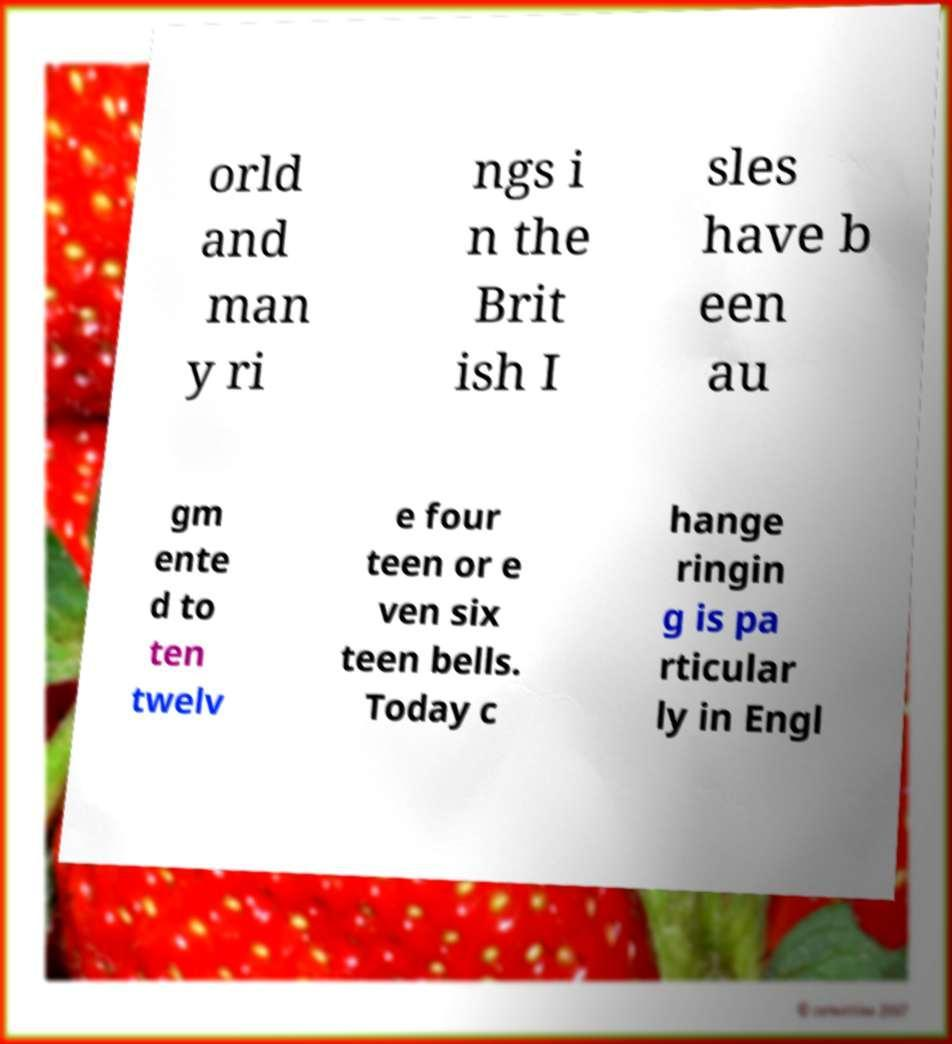What messages or text are displayed in this image? I need them in a readable, typed format. orld and man y ri ngs i n the Brit ish I sles have b een au gm ente d to ten twelv e four teen or e ven six teen bells. Today c hange ringin g is pa rticular ly in Engl 